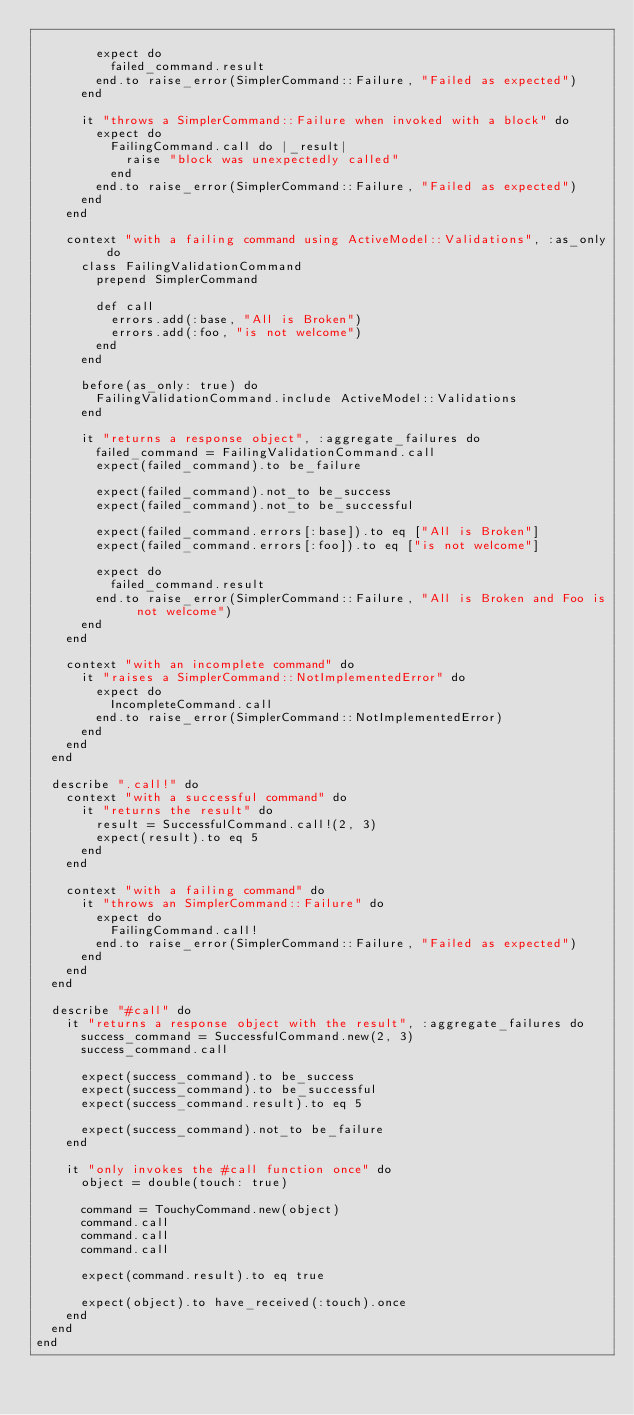<code> <loc_0><loc_0><loc_500><loc_500><_Ruby_>
        expect do
          failed_command.result
        end.to raise_error(SimplerCommand::Failure, "Failed as expected")
      end

      it "throws a SimplerCommand::Failure when invoked with a block" do
        expect do
          FailingCommand.call do |_result|
            raise "block was unexpectedly called"
          end
        end.to raise_error(SimplerCommand::Failure, "Failed as expected")
      end
    end

    context "with a failing command using ActiveModel::Validations", :as_only do
      class FailingValidationCommand
        prepend SimplerCommand

        def call
          errors.add(:base, "All is Broken")
          errors.add(:foo, "is not welcome")
        end
      end

      before(as_only: true) do
        FailingValidationCommand.include ActiveModel::Validations
      end

      it "returns a response object", :aggregate_failures do
        failed_command = FailingValidationCommand.call
        expect(failed_command).to be_failure

        expect(failed_command).not_to be_success
        expect(failed_command).not_to be_successful

        expect(failed_command.errors[:base]).to eq ["All is Broken"]
        expect(failed_command.errors[:foo]).to eq ["is not welcome"]

        expect do
          failed_command.result
        end.to raise_error(SimplerCommand::Failure, "All is Broken and Foo is not welcome")
      end
    end

    context "with an incomplete command" do
      it "raises a SimplerCommand::NotImplementedError" do
        expect do
          IncompleteCommand.call
        end.to raise_error(SimplerCommand::NotImplementedError)
      end
    end
  end

  describe ".call!" do
    context "with a successful command" do
      it "returns the result" do
        result = SuccessfulCommand.call!(2, 3)
        expect(result).to eq 5
      end
    end

    context "with a failing command" do
      it "throws an SimplerCommand::Failure" do
        expect do
          FailingCommand.call!
        end.to raise_error(SimplerCommand::Failure, "Failed as expected")
      end
    end
  end

  describe "#call" do
    it "returns a response object with the result", :aggregate_failures do
      success_command = SuccessfulCommand.new(2, 3)
      success_command.call

      expect(success_command).to be_success
      expect(success_command).to be_successful
      expect(success_command.result).to eq 5

      expect(success_command).not_to be_failure
    end

    it "only invokes the #call function once" do
      object = double(touch: true)

      command = TouchyCommand.new(object)
      command.call
      command.call
      command.call

      expect(command.result).to eq true

      expect(object).to have_received(:touch).once
    end
  end
end
</code> 